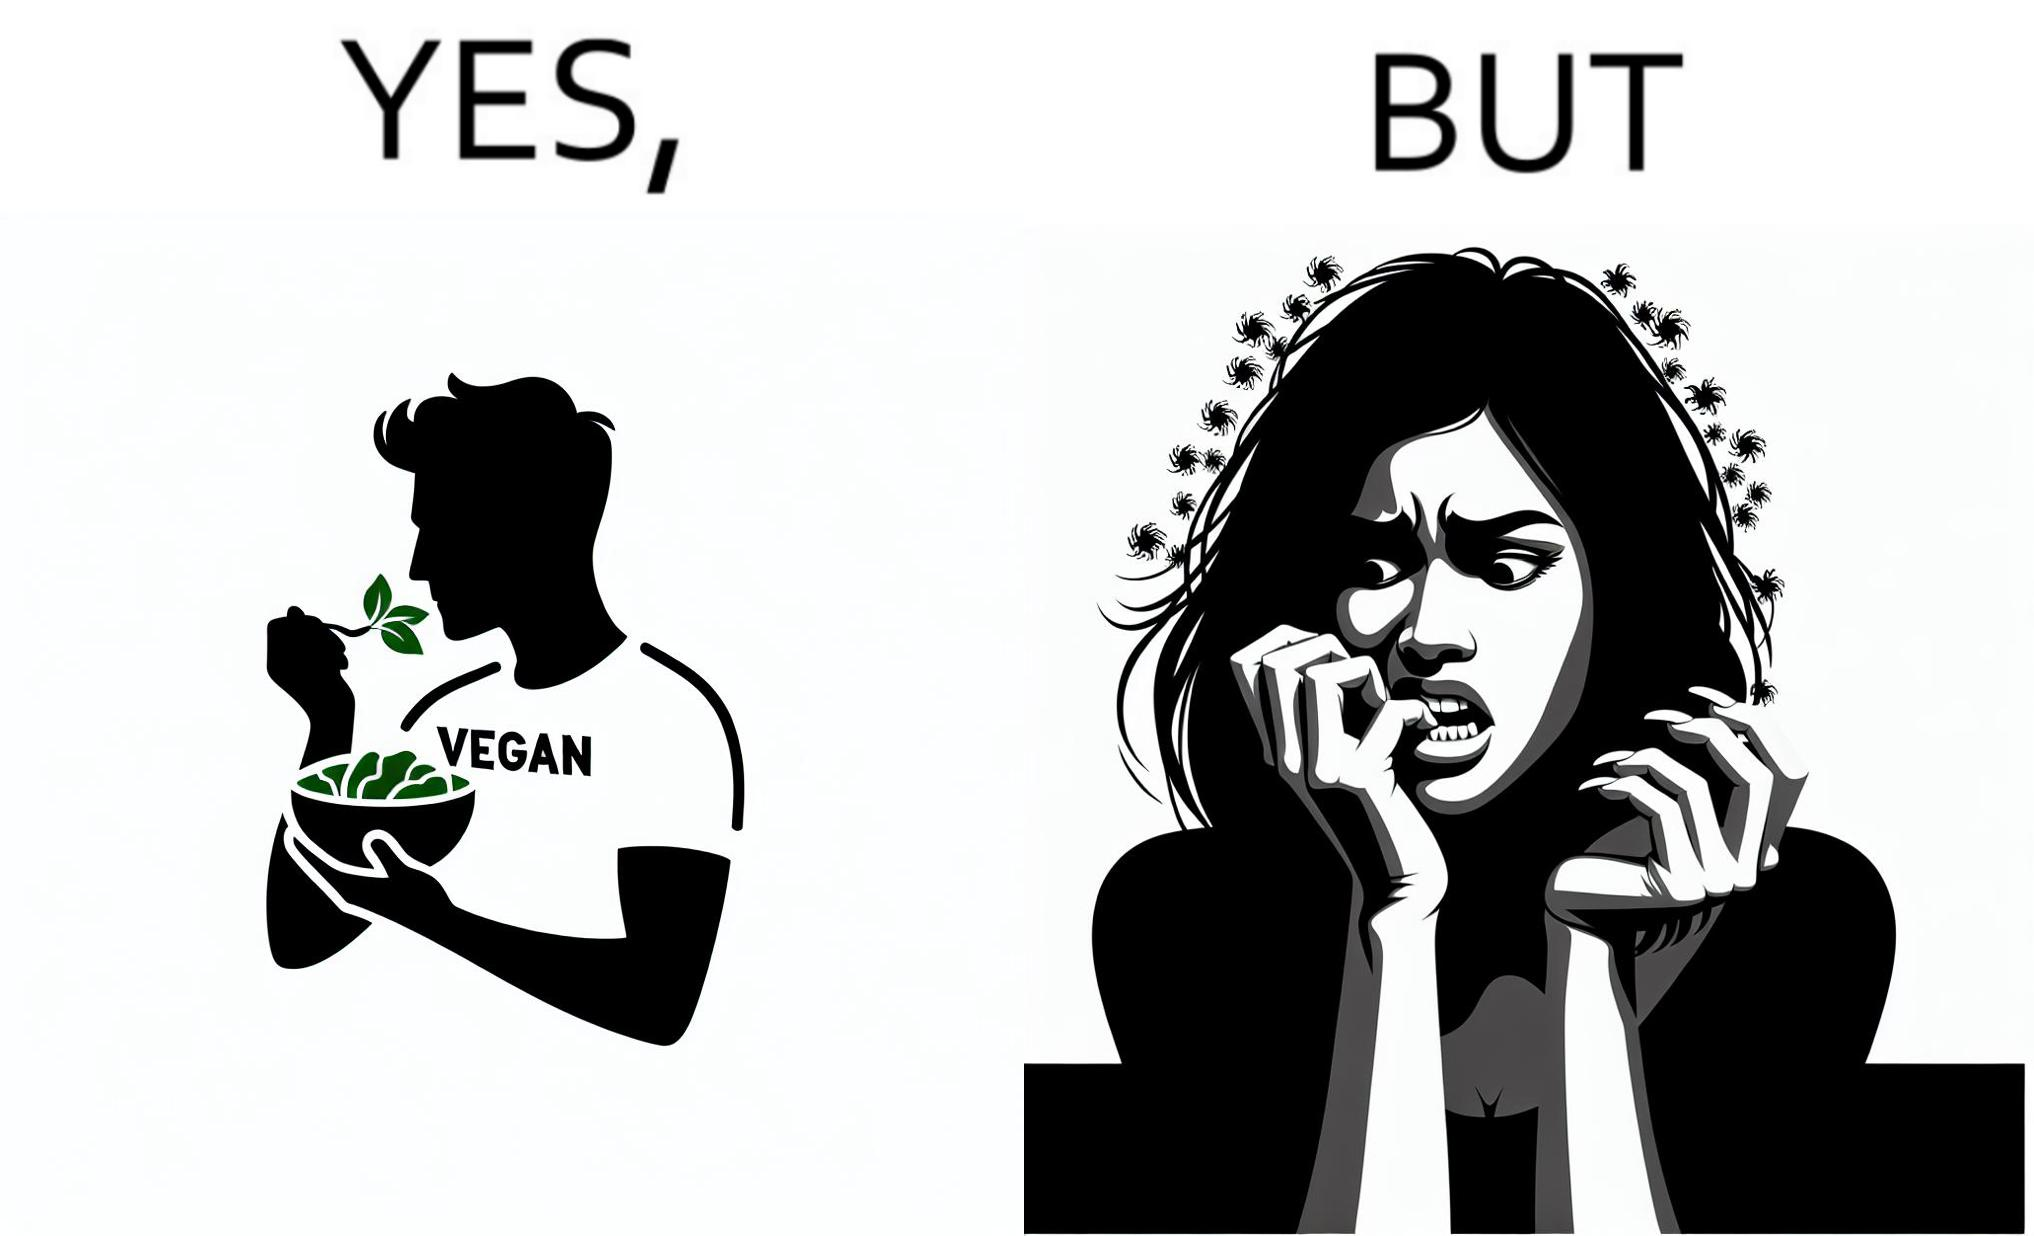Explain why this image is satirical. The image is funny because while the man claims to be vegan, he is biting skin off his own hand. 